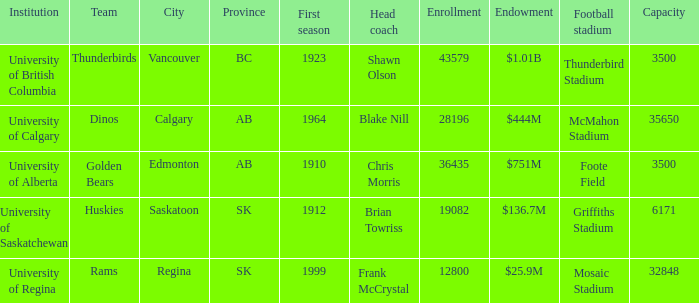In how many cities is the enrollment count 19082? 1.0. 